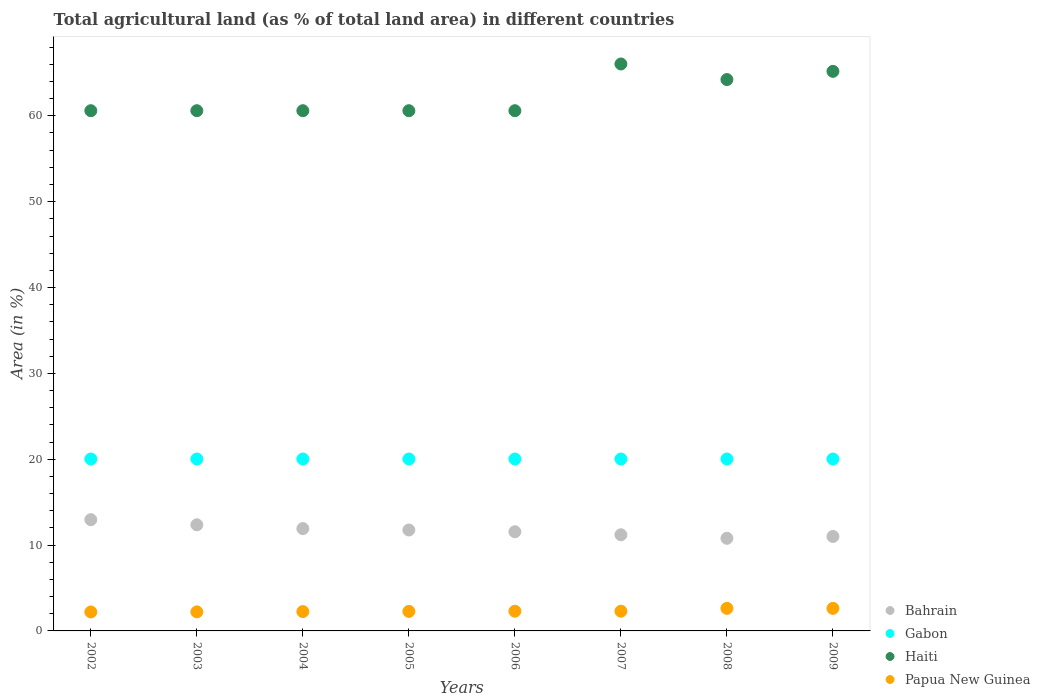What is the percentage of agricultural land in Haiti in 2004?
Keep it short and to the point. 60.6. Across all years, what is the maximum percentage of agricultural land in Haiti?
Offer a terse response. 66.04. Across all years, what is the minimum percentage of agricultural land in Papua New Guinea?
Keep it short and to the point. 2.21. In which year was the percentage of agricultural land in Bahrain maximum?
Your answer should be compact. 2002. In which year was the percentage of agricultural land in Papua New Guinea minimum?
Keep it short and to the point. 2002. What is the total percentage of agricultural land in Gabon in the graph?
Offer a very short reply. 160.2. What is the difference between the percentage of agricultural land in Bahrain in 2003 and that in 2005?
Offer a terse response. 0.6. What is the difference between the percentage of agricultural land in Haiti in 2003 and the percentage of agricultural land in Gabon in 2005?
Your answer should be very brief. 40.57. What is the average percentage of agricultural land in Bahrain per year?
Your answer should be compact. 11.69. In the year 2008, what is the difference between the percentage of agricultural land in Haiti and percentage of agricultural land in Bahrain?
Offer a very short reply. 53.43. In how many years, is the percentage of agricultural land in Gabon greater than 4 %?
Provide a succinct answer. 8. What is the ratio of the percentage of agricultural land in Haiti in 2006 to that in 2007?
Provide a succinct answer. 0.92. Is the percentage of agricultural land in Gabon in 2007 less than that in 2009?
Your response must be concise. No. Is the difference between the percentage of agricultural land in Haiti in 2004 and 2005 greater than the difference between the percentage of agricultural land in Bahrain in 2004 and 2005?
Your response must be concise. No. What is the difference between the highest and the second highest percentage of agricultural land in Bahrain?
Your answer should be very brief. 0.6. What is the difference between the highest and the lowest percentage of agricultural land in Papua New Guinea?
Your answer should be very brief. 0.42. Is it the case that in every year, the sum of the percentage of agricultural land in Papua New Guinea and percentage of agricultural land in Gabon  is greater than the sum of percentage of agricultural land in Haiti and percentage of agricultural land in Bahrain?
Provide a succinct answer. No. Is it the case that in every year, the sum of the percentage of agricultural land in Bahrain and percentage of agricultural land in Papua New Guinea  is greater than the percentage of agricultural land in Gabon?
Give a very brief answer. No. Is the percentage of agricultural land in Bahrain strictly greater than the percentage of agricultural land in Papua New Guinea over the years?
Provide a short and direct response. Yes. Is the percentage of agricultural land in Bahrain strictly less than the percentage of agricultural land in Papua New Guinea over the years?
Keep it short and to the point. No. How many dotlines are there?
Provide a succinct answer. 4. What is the difference between two consecutive major ticks on the Y-axis?
Ensure brevity in your answer.  10. Does the graph contain grids?
Make the answer very short. No. Where does the legend appear in the graph?
Provide a short and direct response. Bottom right. How are the legend labels stacked?
Provide a short and direct response. Vertical. What is the title of the graph?
Make the answer very short. Total agricultural land (as % of total land area) in different countries. Does "Norway" appear as one of the legend labels in the graph?
Provide a short and direct response. No. What is the label or title of the Y-axis?
Provide a succinct answer. Area (in %). What is the Area (in %) in Bahrain in 2002?
Your answer should be very brief. 12.96. What is the Area (in %) in Gabon in 2002?
Offer a terse response. 20.03. What is the Area (in %) of Haiti in 2002?
Provide a succinct answer. 60.6. What is the Area (in %) of Papua New Guinea in 2002?
Ensure brevity in your answer.  2.21. What is the Area (in %) in Bahrain in 2003?
Your response must be concise. 12.36. What is the Area (in %) of Gabon in 2003?
Your response must be concise. 20.03. What is the Area (in %) in Haiti in 2003?
Your response must be concise. 60.6. What is the Area (in %) of Papua New Guinea in 2003?
Make the answer very short. 2.22. What is the Area (in %) in Bahrain in 2004?
Your answer should be compact. 11.92. What is the Area (in %) in Gabon in 2004?
Provide a short and direct response. 20.03. What is the Area (in %) in Haiti in 2004?
Your answer should be very brief. 60.6. What is the Area (in %) of Papua New Guinea in 2004?
Provide a short and direct response. 2.25. What is the Area (in %) of Bahrain in 2005?
Offer a very short reply. 11.76. What is the Area (in %) in Gabon in 2005?
Offer a very short reply. 20.03. What is the Area (in %) of Haiti in 2005?
Give a very brief answer. 60.6. What is the Area (in %) of Papua New Guinea in 2005?
Offer a terse response. 2.27. What is the Area (in %) in Bahrain in 2006?
Provide a short and direct response. 11.55. What is the Area (in %) of Gabon in 2006?
Make the answer very short. 20.03. What is the Area (in %) in Haiti in 2006?
Make the answer very short. 60.6. What is the Area (in %) of Papua New Guinea in 2006?
Your answer should be compact. 2.3. What is the Area (in %) of Gabon in 2007?
Provide a short and direct response. 20.03. What is the Area (in %) in Haiti in 2007?
Ensure brevity in your answer.  66.04. What is the Area (in %) of Papua New Guinea in 2007?
Offer a terse response. 2.3. What is the Area (in %) of Bahrain in 2008?
Give a very brief answer. 10.79. What is the Area (in %) of Gabon in 2008?
Ensure brevity in your answer.  20.03. What is the Area (in %) in Haiti in 2008?
Offer a very short reply. 64.22. What is the Area (in %) of Papua New Guinea in 2008?
Provide a short and direct response. 2.63. What is the Area (in %) in Bahrain in 2009?
Ensure brevity in your answer.  11. What is the Area (in %) in Gabon in 2009?
Offer a very short reply. 20.03. What is the Area (in %) of Haiti in 2009?
Offer a very short reply. 65.18. What is the Area (in %) of Papua New Guinea in 2009?
Provide a succinct answer. 2.63. Across all years, what is the maximum Area (in %) in Bahrain?
Your answer should be compact. 12.96. Across all years, what is the maximum Area (in %) of Gabon?
Your response must be concise. 20.03. Across all years, what is the maximum Area (in %) of Haiti?
Your response must be concise. 66.04. Across all years, what is the maximum Area (in %) in Papua New Guinea?
Make the answer very short. 2.63. Across all years, what is the minimum Area (in %) of Bahrain?
Offer a very short reply. 10.79. Across all years, what is the minimum Area (in %) in Gabon?
Your answer should be very brief. 20.03. Across all years, what is the minimum Area (in %) in Haiti?
Offer a very short reply. 60.6. Across all years, what is the minimum Area (in %) of Papua New Guinea?
Offer a very short reply. 2.21. What is the total Area (in %) in Bahrain in the graph?
Your response must be concise. 93.54. What is the total Area (in %) in Gabon in the graph?
Offer a terse response. 160.2. What is the total Area (in %) of Haiti in the graph?
Offer a terse response. 498.42. What is the total Area (in %) of Papua New Guinea in the graph?
Make the answer very short. 18.8. What is the difference between the Area (in %) in Bahrain in 2002 and that in 2003?
Offer a very short reply. 0.6. What is the difference between the Area (in %) in Gabon in 2002 and that in 2003?
Offer a terse response. 0. What is the difference between the Area (in %) in Haiti in 2002 and that in 2003?
Your answer should be very brief. 0. What is the difference between the Area (in %) in Papua New Guinea in 2002 and that in 2003?
Offer a terse response. -0.01. What is the difference between the Area (in %) of Bahrain in 2002 and that in 2004?
Give a very brief answer. 1.04. What is the difference between the Area (in %) of Haiti in 2002 and that in 2004?
Ensure brevity in your answer.  0. What is the difference between the Area (in %) of Papua New Guinea in 2002 and that in 2004?
Your answer should be compact. -0.04. What is the difference between the Area (in %) in Bahrain in 2002 and that in 2005?
Your response must be concise. 1.2. What is the difference between the Area (in %) in Gabon in 2002 and that in 2005?
Offer a very short reply. 0. What is the difference between the Area (in %) of Papua New Guinea in 2002 and that in 2005?
Provide a succinct answer. -0.07. What is the difference between the Area (in %) in Bahrain in 2002 and that in 2006?
Your answer should be compact. 1.4. What is the difference between the Area (in %) in Papua New Guinea in 2002 and that in 2006?
Offer a terse response. -0.09. What is the difference between the Area (in %) in Bahrain in 2002 and that in 2007?
Keep it short and to the point. 1.76. What is the difference between the Area (in %) in Gabon in 2002 and that in 2007?
Offer a terse response. 0. What is the difference between the Area (in %) of Haiti in 2002 and that in 2007?
Keep it short and to the point. -5.44. What is the difference between the Area (in %) of Papua New Guinea in 2002 and that in 2007?
Give a very brief answer. -0.09. What is the difference between the Area (in %) in Bahrain in 2002 and that in 2008?
Provide a short and direct response. 2.17. What is the difference between the Area (in %) of Haiti in 2002 and that in 2008?
Keep it short and to the point. -3.63. What is the difference between the Area (in %) in Papua New Guinea in 2002 and that in 2008?
Make the answer very short. -0.42. What is the difference between the Area (in %) in Bahrain in 2002 and that in 2009?
Give a very brief answer. 1.96. What is the difference between the Area (in %) in Gabon in 2002 and that in 2009?
Provide a succinct answer. 0. What is the difference between the Area (in %) in Haiti in 2002 and that in 2009?
Offer a very short reply. -4.58. What is the difference between the Area (in %) of Papua New Guinea in 2002 and that in 2009?
Your answer should be very brief. -0.42. What is the difference between the Area (in %) in Bahrain in 2003 and that in 2004?
Your answer should be very brief. 0.44. What is the difference between the Area (in %) in Gabon in 2003 and that in 2004?
Ensure brevity in your answer.  0. What is the difference between the Area (in %) in Papua New Guinea in 2003 and that in 2004?
Make the answer very short. -0.03. What is the difference between the Area (in %) in Bahrain in 2003 and that in 2005?
Your answer should be very brief. 0.6. What is the difference between the Area (in %) of Gabon in 2003 and that in 2005?
Offer a very short reply. 0. What is the difference between the Area (in %) in Papua New Guinea in 2003 and that in 2005?
Offer a very short reply. -0.06. What is the difference between the Area (in %) of Bahrain in 2003 and that in 2006?
Give a very brief answer. 0.81. What is the difference between the Area (in %) in Papua New Guinea in 2003 and that in 2006?
Offer a very short reply. -0.08. What is the difference between the Area (in %) in Bahrain in 2003 and that in 2007?
Provide a short and direct response. 1.16. What is the difference between the Area (in %) of Gabon in 2003 and that in 2007?
Make the answer very short. 0. What is the difference between the Area (in %) in Haiti in 2003 and that in 2007?
Offer a very short reply. -5.44. What is the difference between the Area (in %) in Papua New Guinea in 2003 and that in 2007?
Your answer should be very brief. -0.08. What is the difference between the Area (in %) of Bahrain in 2003 and that in 2008?
Offer a very short reply. 1.57. What is the difference between the Area (in %) of Gabon in 2003 and that in 2008?
Your response must be concise. 0. What is the difference between the Area (in %) of Haiti in 2003 and that in 2008?
Make the answer very short. -3.63. What is the difference between the Area (in %) of Papua New Guinea in 2003 and that in 2008?
Provide a succinct answer. -0.41. What is the difference between the Area (in %) of Bahrain in 2003 and that in 2009?
Give a very brief answer. 1.36. What is the difference between the Area (in %) of Haiti in 2003 and that in 2009?
Offer a terse response. -4.58. What is the difference between the Area (in %) in Papua New Guinea in 2003 and that in 2009?
Keep it short and to the point. -0.41. What is the difference between the Area (in %) in Bahrain in 2004 and that in 2005?
Give a very brief answer. 0.16. What is the difference between the Area (in %) in Haiti in 2004 and that in 2005?
Provide a short and direct response. 0. What is the difference between the Area (in %) of Papua New Guinea in 2004 and that in 2005?
Provide a short and direct response. -0.02. What is the difference between the Area (in %) of Bahrain in 2004 and that in 2006?
Your answer should be very brief. 0.36. What is the difference between the Area (in %) in Papua New Guinea in 2004 and that in 2006?
Your response must be concise. -0.04. What is the difference between the Area (in %) of Bahrain in 2004 and that in 2007?
Provide a short and direct response. 0.72. What is the difference between the Area (in %) in Haiti in 2004 and that in 2007?
Your response must be concise. -5.44. What is the difference between the Area (in %) in Papua New Guinea in 2004 and that in 2007?
Ensure brevity in your answer.  -0.04. What is the difference between the Area (in %) of Bahrain in 2004 and that in 2008?
Offer a very short reply. 1.13. What is the difference between the Area (in %) in Gabon in 2004 and that in 2008?
Make the answer very short. 0. What is the difference between the Area (in %) in Haiti in 2004 and that in 2008?
Your response must be concise. -3.63. What is the difference between the Area (in %) of Papua New Guinea in 2004 and that in 2008?
Offer a very short reply. -0.38. What is the difference between the Area (in %) in Bahrain in 2004 and that in 2009?
Your answer should be very brief. 0.92. What is the difference between the Area (in %) of Haiti in 2004 and that in 2009?
Ensure brevity in your answer.  -4.58. What is the difference between the Area (in %) of Papua New Guinea in 2004 and that in 2009?
Offer a very short reply. -0.38. What is the difference between the Area (in %) of Bahrain in 2005 and that in 2006?
Provide a succinct answer. 0.2. What is the difference between the Area (in %) of Gabon in 2005 and that in 2006?
Make the answer very short. 0. What is the difference between the Area (in %) in Papua New Guinea in 2005 and that in 2006?
Your response must be concise. -0.02. What is the difference between the Area (in %) of Bahrain in 2005 and that in 2007?
Your answer should be compact. 0.56. What is the difference between the Area (in %) of Haiti in 2005 and that in 2007?
Your answer should be compact. -5.44. What is the difference between the Area (in %) in Papua New Guinea in 2005 and that in 2007?
Offer a very short reply. -0.02. What is the difference between the Area (in %) in Bahrain in 2005 and that in 2008?
Offer a very short reply. 0.97. What is the difference between the Area (in %) in Haiti in 2005 and that in 2008?
Your response must be concise. -3.63. What is the difference between the Area (in %) in Papua New Guinea in 2005 and that in 2008?
Offer a very short reply. -0.35. What is the difference between the Area (in %) in Bahrain in 2005 and that in 2009?
Provide a short and direct response. 0.76. What is the difference between the Area (in %) in Gabon in 2005 and that in 2009?
Give a very brief answer. 0. What is the difference between the Area (in %) in Haiti in 2005 and that in 2009?
Keep it short and to the point. -4.58. What is the difference between the Area (in %) in Papua New Guinea in 2005 and that in 2009?
Provide a succinct answer. -0.35. What is the difference between the Area (in %) of Bahrain in 2006 and that in 2007?
Provide a succinct answer. 0.35. What is the difference between the Area (in %) in Haiti in 2006 and that in 2007?
Ensure brevity in your answer.  -5.44. What is the difference between the Area (in %) of Bahrain in 2006 and that in 2008?
Your answer should be compact. 0.76. What is the difference between the Area (in %) of Gabon in 2006 and that in 2008?
Ensure brevity in your answer.  0. What is the difference between the Area (in %) in Haiti in 2006 and that in 2008?
Give a very brief answer. -3.63. What is the difference between the Area (in %) of Papua New Guinea in 2006 and that in 2008?
Keep it short and to the point. -0.33. What is the difference between the Area (in %) of Bahrain in 2006 and that in 2009?
Give a very brief answer. 0.55. What is the difference between the Area (in %) in Gabon in 2006 and that in 2009?
Your answer should be very brief. 0. What is the difference between the Area (in %) of Haiti in 2006 and that in 2009?
Provide a short and direct response. -4.58. What is the difference between the Area (in %) in Papua New Guinea in 2006 and that in 2009?
Ensure brevity in your answer.  -0.33. What is the difference between the Area (in %) of Bahrain in 2007 and that in 2008?
Give a very brief answer. 0.41. What is the difference between the Area (in %) in Gabon in 2007 and that in 2008?
Your response must be concise. 0. What is the difference between the Area (in %) of Haiti in 2007 and that in 2008?
Your response must be concise. 1.81. What is the difference between the Area (in %) of Papua New Guinea in 2007 and that in 2008?
Offer a terse response. -0.33. What is the difference between the Area (in %) of Bahrain in 2007 and that in 2009?
Ensure brevity in your answer.  0.2. What is the difference between the Area (in %) of Haiti in 2007 and that in 2009?
Provide a short and direct response. 0.86. What is the difference between the Area (in %) of Papua New Guinea in 2007 and that in 2009?
Your answer should be very brief. -0.33. What is the difference between the Area (in %) of Bahrain in 2008 and that in 2009?
Provide a short and direct response. -0.21. What is the difference between the Area (in %) of Gabon in 2008 and that in 2009?
Your answer should be very brief. 0. What is the difference between the Area (in %) in Haiti in 2008 and that in 2009?
Provide a succinct answer. -0.96. What is the difference between the Area (in %) of Bahrain in 2002 and the Area (in %) of Gabon in 2003?
Keep it short and to the point. -7.07. What is the difference between the Area (in %) in Bahrain in 2002 and the Area (in %) in Haiti in 2003?
Keep it short and to the point. -47.64. What is the difference between the Area (in %) of Bahrain in 2002 and the Area (in %) of Papua New Guinea in 2003?
Make the answer very short. 10.74. What is the difference between the Area (in %) in Gabon in 2002 and the Area (in %) in Haiti in 2003?
Offer a very short reply. -40.57. What is the difference between the Area (in %) of Gabon in 2002 and the Area (in %) of Papua New Guinea in 2003?
Keep it short and to the point. 17.81. What is the difference between the Area (in %) in Haiti in 2002 and the Area (in %) in Papua New Guinea in 2003?
Give a very brief answer. 58.38. What is the difference between the Area (in %) in Bahrain in 2002 and the Area (in %) in Gabon in 2004?
Your answer should be compact. -7.07. What is the difference between the Area (in %) of Bahrain in 2002 and the Area (in %) of Haiti in 2004?
Ensure brevity in your answer.  -47.64. What is the difference between the Area (in %) in Bahrain in 2002 and the Area (in %) in Papua New Guinea in 2004?
Give a very brief answer. 10.71. What is the difference between the Area (in %) in Gabon in 2002 and the Area (in %) in Haiti in 2004?
Your answer should be very brief. -40.57. What is the difference between the Area (in %) of Gabon in 2002 and the Area (in %) of Papua New Guinea in 2004?
Provide a succinct answer. 17.77. What is the difference between the Area (in %) in Haiti in 2002 and the Area (in %) in Papua New Guinea in 2004?
Keep it short and to the point. 58.34. What is the difference between the Area (in %) of Bahrain in 2002 and the Area (in %) of Gabon in 2005?
Your answer should be compact. -7.07. What is the difference between the Area (in %) of Bahrain in 2002 and the Area (in %) of Haiti in 2005?
Ensure brevity in your answer.  -47.64. What is the difference between the Area (in %) in Bahrain in 2002 and the Area (in %) in Papua New Guinea in 2005?
Provide a succinct answer. 10.68. What is the difference between the Area (in %) of Gabon in 2002 and the Area (in %) of Haiti in 2005?
Ensure brevity in your answer.  -40.57. What is the difference between the Area (in %) in Gabon in 2002 and the Area (in %) in Papua New Guinea in 2005?
Make the answer very short. 17.75. What is the difference between the Area (in %) of Haiti in 2002 and the Area (in %) of Papua New Guinea in 2005?
Make the answer very short. 58.32. What is the difference between the Area (in %) of Bahrain in 2002 and the Area (in %) of Gabon in 2006?
Your response must be concise. -7.07. What is the difference between the Area (in %) in Bahrain in 2002 and the Area (in %) in Haiti in 2006?
Make the answer very short. -47.64. What is the difference between the Area (in %) of Bahrain in 2002 and the Area (in %) of Papua New Guinea in 2006?
Your response must be concise. 10.66. What is the difference between the Area (in %) of Gabon in 2002 and the Area (in %) of Haiti in 2006?
Offer a very short reply. -40.57. What is the difference between the Area (in %) of Gabon in 2002 and the Area (in %) of Papua New Guinea in 2006?
Give a very brief answer. 17.73. What is the difference between the Area (in %) of Haiti in 2002 and the Area (in %) of Papua New Guinea in 2006?
Provide a short and direct response. 58.3. What is the difference between the Area (in %) of Bahrain in 2002 and the Area (in %) of Gabon in 2007?
Make the answer very short. -7.07. What is the difference between the Area (in %) in Bahrain in 2002 and the Area (in %) in Haiti in 2007?
Keep it short and to the point. -53.08. What is the difference between the Area (in %) of Bahrain in 2002 and the Area (in %) of Papua New Guinea in 2007?
Your answer should be very brief. 10.66. What is the difference between the Area (in %) in Gabon in 2002 and the Area (in %) in Haiti in 2007?
Provide a succinct answer. -46.01. What is the difference between the Area (in %) in Gabon in 2002 and the Area (in %) in Papua New Guinea in 2007?
Offer a very short reply. 17.73. What is the difference between the Area (in %) of Haiti in 2002 and the Area (in %) of Papua New Guinea in 2007?
Make the answer very short. 58.3. What is the difference between the Area (in %) of Bahrain in 2002 and the Area (in %) of Gabon in 2008?
Your answer should be compact. -7.07. What is the difference between the Area (in %) in Bahrain in 2002 and the Area (in %) in Haiti in 2008?
Offer a very short reply. -51.27. What is the difference between the Area (in %) in Bahrain in 2002 and the Area (in %) in Papua New Guinea in 2008?
Your answer should be very brief. 10.33. What is the difference between the Area (in %) of Gabon in 2002 and the Area (in %) of Haiti in 2008?
Offer a very short reply. -44.2. What is the difference between the Area (in %) of Gabon in 2002 and the Area (in %) of Papua New Guinea in 2008?
Make the answer very short. 17.4. What is the difference between the Area (in %) of Haiti in 2002 and the Area (in %) of Papua New Guinea in 2008?
Give a very brief answer. 57.97. What is the difference between the Area (in %) in Bahrain in 2002 and the Area (in %) in Gabon in 2009?
Provide a succinct answer. -7.07. What is the difference between the Area (in %) in Bahrain in 2002 and the Area (in %) in Haiti in 2009?
Give a very brief answer. -52.22. What is the difference between the Area (in %) of Bahrain in 2002 and the Area (in %) of Papua New Guinea in 2009?
Ensure brevity in your answer.  10.33. What is the difference between the Area (in %) in Gabon in 2002 and the Area (in %) in Haiti in 2009?
Provide a succinct answer. -45.15. What is the difference between the Area (in %) in Gabon in 2002 and the Area (in %) in Papua New Guinea in 2009?
Your response must be concise. 17.4. What is the difference between the Area (in %) in Haiti in 2002 and the Area (in %) in Papua New Guinea in 2009?
Keep it short and to the point. 57.97. What is the difference between the Area (in %) in Bahrain in 2003 and the Area (in %) in Gabon in 2004?
Make the answer very short. -7.66. What is the difference between the Area (in %) of Bahrain in 2003 and the Area (in %) of Haiti in 2004?
Make the answer very short. -48.23. What is the difference between the Area (in %) in Bahrain in 2003 and the Area (in %) in Papua New Guinea in 2004?
Provide a succinct answer. 10.11. What is the difference between the Area (in %) in Gabon in 2003 and the Area (in %) in Haiti in 2004?
Provide a short and direct response. -40.57. What is the difference between the Area (in %) of Gabon in 2003 and the Area (in %) of Papua New Guinea in 2004?
Ensure brevity in your answer.  17.77. What is the difference between the Area (in %) in Haiti in 2003 and the Area (in %) in Papua New Guinea in 2004?
Give a very brief answer. 58.34. What is the difference between the Area (in %) in Bahrain in 2003 and the Area (in %) in Gabon in 2005?
Offer a terse response. -7.66. What is the difference between the Area (in %) in Bahrain in 2003 and the Area (in %) in Haiti in 2005?
Your answer should be compact. -48.23. What is the difference between the Area (in %) in Bahrain in 2003 and the Area (in %) in Papua New Guinea in 2005?
Your answer should be very brief. 10.09. What is the difference between the Area (in %) in Gabon in 2003 and the Area (in %) in Haiti in 2005?
Your response must be concise. -40.57. What is the difference between the Area (in %) in Gabon in 2003 and the Area (in %) in Papua New Guinea in 2005?
Give a very brief answer. 17.75. What is the difference between the Area (in %) in Haiti in 2003 and the Area (in %) in Papua New Guinea in 2005?
Keep it short and to the point. 58.32. What is the difference between the Area (in %) of Bahrain in 2003 and the Area (in %) of Gabon in 2006?
Give a very brief answer. -7.66. What is the difference between the Area (in %) of Bahrain in 2003 and the Area (in %) of Haiti in 2006?
Your answer should be compact. -48.23. What is the difference between the Area (in %) in Bahrain in 2003 and the Area (in %) in Papua New Guinea in 2006?
Offer a terse response. 10.06. What is the difference between the Area (in %) in Gabon in 2003 and the Area (in %) in Haiti in 2006?
Keep it short and to the point. -40.57. What is the difference between the Area (in %) in Gabon in 2003 and the Area (in %) in Papua New Guinea in 2006?
Your answer should be very brief. 17.73. What is the difference between the Area (in %) of Haiti in 2003 and the Area (in %) of Papua New Guinea in 2006?
Keep it short and to the point. 58.3. What is the difference between the Area (in %) in Bahrain in 2003 and the Area (in %) in Gabon in 2007?
Keep it short and to the point. -7.66. What is the difference between the Area (in %) of Bahrain in 2003 and the Area (in %) of Haiti in 2007?
Provide a short and direct response. -53.68. What is the difference between the Area (in %) of Bahrain in 2003 and the Area (in %) of Papua New Guinea in 2007?
Provide a succinct answer. 10.06. What is the difference between the Area (in %) of Gabon in 2003 and the Area (in %) of Haiti in 2007?
Your answer should be very brief. -46.01. What is the difference between the Area (in %) of Gabon in 2003 and the Area (in %) of Papua New Guinea in 2007?
Keep it short and to the point. 17.73. What is the difference between the Area (in %) of Haiti in 2003 and the Area (in %) of Papua New Guinea in 2007?
Your answer should be very brief. 58.3. What is the difference between the Area (in %) in Bahrain in 2003 and the Area (in %) in Gabon in 2008?
Offer a terse response. -7.66. What is the difference between the Area (in %) of Bahrain in 2003 and the Area (in %) of Haiti in 2008?
Offer a very short reply. -51.86. What is the difference between the Area (in %) in Bahrain in 2003 and the Area (in %) in Papua New Guinea in 2008?
Offer a terse response. 9.73. What is the difference between the Area (in %) of Gabon in 2003 and the Area (in %) of Haiti in 2008?
Provide a succinct answer. -44.2. What is the difference between the Area (in %) of Gabon in 2003 and the Area (in %) of Papua New Guinea in 2008?
Your answer should be very brief. 17.4. What is the difference between the Area (in %) in Haiti in 2003 and the Area (in %) in Papua New Guinea in 2008?
Provide a succinct answer. 57.97. What is the difference between the Area (in %) in Bahrain in 2003 and the Area (in %) in Gabon in 2009?
Keep it short and to the point. -7.66. What is the difference between the Area (in %) in Bahrain in 2003 and the Area (in %) in Haiti in 2009?
Offer a terse response. -52.82. What is the difference between the Area (in %) in Bahrain in 2003 and the Area (in %) in Papua New Guinea in 2009?
Ensure brevity in your answer.  9.73. What is the difference between the Area (in %) of Gabon in 2003 and the Area (in %) of Haiti in 2009?
Give a very brief answer. -45.15. What is the difference between the Area (in %) in Gabon in 2003 and the Area (in %) in Papua New Guinea in 2009?
Offer a very short reply. 17.4. What is the difference between the Area (in %) of Haiti in 2003 and the Area (in %) of Papua New Guinea in 2009?
Give a very brief answer. 57.97. What is the difference between the Area (in %) in Bahrain in 2004 and the Area (in %) in Gabon in 2005?
Offer a terse response. -8.11. What is the difference between the Area (in %) in Bahrain in 2004 and the Area (in %) in Haiti in 2005?
Make the answer very short. -48.68. What is the difference between the Area (in %) of Bahrain in 2004 and the Area (in %) of Papua New Guinea in 2005?
Make the answer very short. 9.64. What is the difference between the Area (in %) of Gabon in 2004 and the Area (in %) of Haiti in 2005?
Give a very brief answer. -40.57. What is the difference between the Area (in %) of Gabon in 2004 and the Area (in %) of Papua New Guinea in 2005?
Ensure brevity in your answer.  17.75. What is the difference between the Area (in %) of Haiti in 2004 and the Area (in %) of Papua New Guinea in 2005?
Offer a very short reply. 58.32. What is the difference between the Area (in %) of Bahrain in 2004 and the Area (in %) of Gabon in 2006?
Your response must be concise. -8.11. What is the difference between the Area (in %) of Bahrain in 2004 and the Area (in %) of Haiti in 2006?
Keep it short and to the point. -48.68. What is the difference between the Area (in %) of Bahrain in 2004 and the Area (in %) of Papua New Guinea in 2006?
Your answer should be compact. 9.62. What is the difference between the Area (in %) in Gabon in 2004 and the Area (in %) in Haiti in 2006?
Keep it short and to the point. -40.57. What is the difference between the Area (in %) in Gabon in 2004 and the Area (in %) in Papua New Guinea in 2006?
Give a very brief answer. 17.73. What is the difference between the Area (in %) of Haiti in 2004 and the Area (in %) of Papua New Guinea in 2006?
Offer a terse response. 58.3. What is the difference between the Area (in %) in Bahrain in 2004 and the Area (in %) in Gabon in 2007?
Keep it short and to the point. -8.11. What is the difference between the Area (in %) in Bahrain in 2004 and the Area (in %) in Haiti in 2007?
Offer a very short reply. -54.12. What is the difference between the Area (in %) of Bahrain in 2004 and the Area (in %) of Papua New Guinea in 2007?
Make the answer very short. 9.62. What is the difference between the Area (in %) in Gabon in 2004 and the Area (in %) in Haiti in 2007?
Keep it short and to the point. -46.01. What is the difference between the Area (in %) in Gabon in 2004 and the Area (in %) in Papua New Guinea in 2007?
Ensure brevity in your answer.  17.73. What is the difference between the Area (in %) of Haiti in 2004 and the Area (in %) of Papua New Guinea in 2007?
Give a very brief answer. 58.3. What is the difference between the Area (in %) in Bahrain in 2004 and the Area (in %) in Gabon in 2008?
Give a very brief answer. -8.11. What is the difference between the Area (in %) in Bahrain in 2004 and the Area (in %) in Haiti in 2008?
Offer a very short reply. -52.31. What is the difference between the Area (in %) in Bahrain in 2004 and the Area (in %) in Papua New Guinea in 2008?
Offer a terse response. 9.29. What is the difference between the Area (in %) of Gabon in 2004 and the Area (in %) of Haiti in 2008?
Ensure brevity in your answer.  -44.2. What is the difference between the Area (in %) in Gabon in 2004 and the Area (in %) in Papua New Guinea in 2008?
Provide a succinct answer. 17.4. What is the difference between the Area (in %) of Haiti in 2004 and the Area (in %) of Papua New Guinea in 2008?
Your answer should be very brief. 57.97. What is the difference between the Area (in %) in Bahrain in 2004 and the Area (in %) in Gabon in 2009?
Ensure brevity in your answer.  -8.11. What is the difference between the Area (in %) in Bahrain in 2004 and the Area (in %) in Haiti in 2009?
Give a very brief answer. -53.26. What is the difference between the Area (in %) of Bahrain in 2004 and the Area (in %) of Papua New Guinea in 2009?
Ensure brevity in your answer.  9.29. What is the difference between the Area (in %) of Gabon in 2004 and the Area (in %) of Haiti in 2009?
Make the answer very short. -45.15. What is the difference between the Area (in %) of Gabon in 2004 and the Area (in %) of Papua New Guinea in 2009?
Keep it short and to the point. 17.4. What is the difference between the Area (in %) in Haiti in 2004 and the Area (in %) in Papua New Guinea in 2009?
Keep it short and to the point. 57.97. What is the difference between the Area (in %) of Bahrain in 2005 and the Area (in %) of Gabon in 2006?
Make the answer very short. -8.27. What is the difference between the Area (in %) of Bahrain in 2005 and the Area (in %) of Haiti in 2006?
Offer a very short reply. -48.84. What is the difference between the Area (in %) of Bahrain in 2005 and the Area (in %) of Papua New Guinea in 2006?
Your response must be concise. 9.46. What is the difference between the Area (in %) of Gabon in 2005 and the Area (in %) of Haiti in 2006?
Your answer should be compact. -40.57. What is the difference between the Area (in %) in Gabon in 2005 and the Area (in %) in Papua New Guinea in 2006?
Keep it short and to the point. 17.73. What is the difference between the Area (in %) in Haiti in 2005 and the Area (in %) in Papua New Guinea in 2006?
Make the answer very short. 58.3. What is the difference between the Area (in %) of Bahrain in 2005 and the Area (in %) of Gabon in 2007?
Give a very brief answer. -8.27. What is the difference between the Area (in %) of Bahrain in 2005 and the Area (in %) of Haiti in 2007?
Keep it short and to the point. -54.28. What is the difference between the Area (in %) in Bahrain in 2005 and the Area (in %) in Papua New Guinea in 2007?
Your answer should be very brief. 9.46. What is the difference between the Area (in %) in Gabon in 2005 and the Area (in %) in Haiti in 2007?
Ensure brevity in your answer.  -46.01. What is the difference between the Area (in %) of Gabon in 2005 and the Area (in %) of Papua New Guinea in 2007?
Provide a succinct answer. 17.73. What is the difference between the Area (in %) of Haiti in 2005 and the Area (in %) of Papua New Guinea in 2007?
Keep it short and to the point. 58.3. What is the difference between the Area (in %) in Bahrain in 2005 and the Area (in %) in Gabon in 2008?
Make the answer very short. -8.27. What is the difference between the Area (in %) of Bahrain in 2005 and the Area (in %) of Haiti in 2008?
Offer a terse response. -52.47. What is the difference between the Area (in %) in Bahrain in 2005 and the Area (in %) in Papua New Guinea in 2008?
Offer a terse response. 9.13. What is the difference between the Area (in %) in Gabon in 2005 and the Area (in %) in Haiti in 2008?
Provide a succinct answer. -44.2. What is the difference between the Area (in %) of Gabon in 2005 and the Area (in %) of Papua New Guinea in 2008?
Give a very brief answer. 17.4. What is the difference between the Area (in %) of Haiti in 2005 and the Area (in %) of Papua New Guinea in 2008?
Offer a very short reply. 57.97. What is the difference between the Area (in %) of Bahrain in 2005 and the Area (in %) of Gabon in 2009?
Provide a short and direct response. -8.27. What is the difference between the Area (in %) in Bahrain in 2005 and the Area (in %) in Haiti in 2009?
Offer a terse response. -53.42. What is the difference between the Area (in %) of Bahrain in 2005 and the Area (in %) of Papua New Guinea in 2009?
Offer a very short reply. 9.13. What is the difference between the Area (in %) in Gabon in 2005 and the Area (in %) in Haiti in 2009?
Offer a very short reply. -45.15. What is the difference between the Area (in %) of Gabon in 2005 and the Area (in %) of Papua New Guinea in 2009?
Your answer should be compact. 17.4. What is the difference between the Area (in %) in Haiti in 2005 and the Area (in %) in Papua New Guinea in 2009?
Your response must be concise. 57.97. What is the difference between the Area (in %) in Bahrain in 2006 and the Area (in %) in Gabon in 2007?
Keep it short and to the point. -8.47. What is the difference between the Area (in %) of Bahrain in 2006 and the Area (in %) of Haiti in 2007?
Your response must be concise. -54.48. What is the difference between the Area (in %) in Bahrain in 2006 and the Area (in %) in Papua New Guinea in 2007?
Keep it short and to the point. 9.26. What is the difference between the Area (in %) in Gabon in 2006 and the Area (in %) in Haiti in 2007?
Give a very brief answer. -46.01. What is the difference between the Area (in %) in Gabon in 2006 and the Area (in %) in Papua New Guinea in 2007?
Provide a short and direct response. 17.73. What is the difference between the Area (in %) of Haiti in 2006 and the Area (in %) of Papua New Guinea in 2007?
Provide a succinct answer. 58.3. What is the difference between the Area (in %) of Bahrain in 2006 and the Area (in %) of Gabon in 2008?
Keep it short and to the point. -8.47. What is the difference between the Area (in %) of Bahrain in 2006 and the Area (in %) of Haiti in 2008?
Your answer should be compact. -52.67. What is the difference between the Area (in %) of Bahrain in 2006 and the Area (in %) of Papua New Guinea in 2008?
Offer a very short reply. 8.93. What is the difference between the Area (in %) in Gabon in 2006 and the Area (in %) in Haiti in 2008?
Provide a short and direct response. -44.2. What is the difference between the Area (in %) of Gabon in 2006 and the Area (in %) of Papua New Guinea in 2008?
Your answer should be very brief. 17.4. What is the difference between the Area (in %) in Haiti in 2006 and the Area (in %) in Papua New Guinea in 2008?
Offer a terse response. 57.97. What is the difference between the Area (in %) of Bahrain in 2006 and the Area (in %) of Gabon in 2009?
Make the answer very short. -8.47. What is the difference between the Area (in %) in Bahrain in 2006 and the Area (in %) in Haiti in 2009?
Ensure brevity in your answer.  -53.62. What is the difference between the Area (in %) in Bahrain in 2006 and the Area (in %) in Papua New Guinea in 2009?
Provide a succinct answer. 8.93. What is the difference between the Area (in %) in Gabon in 2006 and the Area (in %) in Haiti in 2009?
Provide a short and direct response. -45.15. What is the difference between the Area (in %) of Gabon in 2006 and the Area (in %) of Papua New Guinea in 2009?
Your answer should be compact. 17.4. What is the difference between the Area (in %) of Haiti in 2006 and the Area (in %) of Papua New Guinea in 2009?
Your response must be concise. 57.97. What is the difference between the Area (in %) of Bahrain in 2007 and the Area (in %) of Gabon in 2008?
Your answer should be very brief. -8.83. What is the difference between the Area (in %) of Bahrain in 2007 and the Area (in %) of Haiti in 2008?
Provide a succinct answer. -53.02. What is the difference between the Area (in %) in Bahrain in 2007 and the Area (in %) in Papua New Guinea in 2008?
Your response must be concise. 8.57. What is the difference between the Area (in %) in Gabon in 2007 and the Area (in %) in Haiti in 2008?
Your answer should be very brief. -44.2. What is the difference between the Area (in %) in Gabon in 2007 and the Area (in %) in Papua New Guinea in 2008?
Your response must be concise. 17.4. What is the difference between the Area (in %) of Haiti in 2007 and the Area (in %) of Papua New Guinea in 2008?
Your answer should be very brief. 63.41. What is the difference between the Area (in %) of Bahrain in 2007 and the Area (in %) of Gabon in 2009?
Keep it short and to the point. -8.83. What is the difference between the Area (in %) in Bahrain in 2007 and the Area (in %) in Haiti in 2009?
Your response must be concise. -53.98. What is the difference between the Area (in %) in Bahrain in 2007 and the Area (in %) in Papua New Guinea in 2009?
Provide a short and direct response. 8.57. What is the difference between the Area (in %) in Gabon in 2007 and the Area (in %) in Haiti in 2009?
Keep it short and to the point. -45.15. What is the difference between the Area (in %) of Gabon in 2007 and the Area (in %) of Papua New Guinea in 2009?
Your answer should be compact. 17.4. What is the difference between the Area (in %) of Haiti in 2007 and the Area (in %) of Papua New Guinea in 2009?
Your answer should be compact. 63.41. What is the difference between the Area (in %) in Bahrain in 2008 and the Area (in %) in Gabon in 2009?
Make the answer very short. -9.24. What is the difference between the Area (in %) in Bahrain in 2008 and the Area (in %) in Haiti in 2009?
Provide a succinct answer. -54.39. What is the difference between the Area (in %) in Bahrain in 2008 and the Area (in %) in Papua New Guinea in 2009?
Your answer should be compact. 8.16. What is the difference between the Area (in %) in Gabon in 2008 and the Area (in %) in Haiti in 2009?
Offer a very short reply. -45.15. What is the difference between the Area (in %) of Gabon in 2008 and the Area (in %) of Papua New Guinea in 2009?
Offer a very short reply. 17.4. What is the difference between the Area (in %) of Haiti in 2008 and the Area (in %) of Papua New Guinea in 2009?
Offer a very short reply. 61.6. What is the average Area (in %) of Bahrain per year?
Keep it short and to the point. 11.69. What is the average Area (in %) in Gabon per year?
Ensure brevity in your answer.  20.03. What is the average Area (in %) of Haiti per year?
Your response must be concise. 62.3. What is the average Area (in %) in Papua New Guinea per year?
Keep it short and to the point. 2.35. In the year 2002, what is the difference between the Area (in %) in Bahrain and Area (in %) in Gabon?
Your answer should be very brief. -7.07. In the year 2002, what is the difference between the Area (in %) of Bahrain and Area (in %) of Haiti?
Your answer should be compact. -47.64. In the year 2002, what is the difference between the Area (in %) in Bahrain and Area (in %) in Papua New Guinea?
Provide a succinct answer. 10.75. In the year 2002, what is the difference between the Area (in %) of Gabon and Area (in %) of Haiti?
Ensure brevity in your answer.  -40.57. In the year 2002, what is the difference between the Area (in %) of Gabon and Area (in %) of Papua New Guinea?
Provide a short and direct response. 17.82. In the year 2002, what is the difference between the Area (in %) of Haiti and Area (in %) of Papua New Guinea?
Give a very brief answer. 58.39. In the year 2003, what is the difference between the Area (in %) in Bahrain and Area (in %) in Gabon?
Offer a very short reply. -7.66. In the year 2003, what is the difference between the Area (in %) in Bahrain and Area (in %) in Haiti?
Offer a terse response. -48.23. In the year 2003, what is the difference between the Area (in %) in Bahrain and Area (in %) in Papua New Guinea?
Your answer should be compact. 10.14. In the year 2003, what is the difference between the Area (in %) of Gabon and Area (in %) of Haiti?
Ensure brevity in your answer.  -40.57. In the year 2003, what is the difference between the Area (in %) of Gabon and Area (in %) of Papua New Guinea?
Offer a terse response. 17.81. In the year 2003, what is the difference between the Area (in %) in Haiti and Area (in %) in Papua New Guinea?
Your response must be concise. 58.38. In the year 2004, what is the difference between the Area (in %) in Bahrain and Area (in %) in Gabon?
Offer a very short reply. -8.11. In the year 2004, what is the difference between the Area (in %) in Bahrain and Area (in %) in Haiti?
Give a very brief answer. -48.68. In the year 2004, what is the difference between the Area (in %) of Bahrain and Area (in %) of Papua New Guinea?
Ensure brevity in your answer.  9.67. In the year 2004, what is the difference between the Area (in %) of Gabon and Area (in %) of Haiti?
Offer a very short reply. -40.57. In the year 2004, what is the difference between the Area (in %) in Gabon and Area (in %) in Papua New Guinea?
Offer a terse response. 17.77. In the year 2004, what is the difference between the Area (in %) in Haiti and Area (in %) in Papua New Guinea?
Your answer should be very brief. 58.34. In the year 2005, what is the difference between the Area (in %) of Bahrain and Area (in %) of Gabon?
Ensure brevity in your answer.  -8.27. In the year 2005, what is the difference between the Area (in %) in Bahrain and Area (in %) in Haiti?
Your answer should be compact. -48.84. In the year 2005, what is the difference between the Area (in %) in Bahrain and Area (in %) in Papua New Guinea?
Offer a terse response. 9.48. In the year 2005, what is the difference between the Area (in %) of Gabon and Area (in %) of Haiti?
Offer a terse response. -40.57. In the year 2005, what is the difference between the Area (in %) in Gabon and Area (in %) in Papua New Guinea?
Provide a short and direct response. 17.75. In the year 2005, what is the difference between the Area (in %) of Haiti and Area (in %) of Papua New Guinea?
Provide a short and direct response. 58.32. In the year 2006, what is the difference between the Area (in %) in Bahrain and Area (in %) in Gabon?
Offer a very short reply. -8.47. In the year 2006, what is the difference between the Area (in %) in Bahrain and Area (in %) in Haiti?
Offer a terse response. -49.04. In the year 2006, what is the difference between the Area (in %) of Bahrain and Area (in %) of Papua New Guinea?
Offer a terse response. 9.26. In the year 2006, what is the difference between the Area (in %) in Gabon and Area (in %) in Haiti?
Your response must be concise. -40.57. In the year 2006, what is the difference between the Area (in %) of Gabon and Area (in %) of Papua New Guinea?
Your answer should be compact. 17.73. In the year 2006, what is the difference between the Area (in %) in Haiti and Area (in %) in Papua New Guinea?
Keep it short and to the point. 58.3. In the year 2007, what is the difference between the Area (in %) of Bahrain and Area (in %) of Gabon?
Keep it short and to the point. -8.83. In the year 2007, what is the difference between the Area (in %) in Bahrain and Area (in %) in Haiti?
Provide a succinct answer. -54.84. In the year 2007, what is the difference between the Area (in %) of Bahrain and Area (in %) of Papua New Guinea?
Ensure brevity in your answer.  8.9. In the year 2007, what is the difference between the Area (in %) in Gabon and Area (in %) in Haiti?
Keep it short and to the point. -46.01. In the year 2007, what is the difference between the Area (in %) of Gabon and Area (in %) of Papua New Guinea?
Offer a very short reply. 17.73. In the year 2007, what is the difference between the Area (in %) of Haiti and Area (in %) of Papua New Guinea?
Provide a short and direct response. 63.74. In the year 2008, what is the difference between the Area (in %) in Bahrain and Area (in %) in Gabon?
Provide a short and direct response. -9.24. In the year 2008, what is the difference between the Area (in %) in Bahrain and Area (in %) in Haiti?
Keep it short and to the point. -53.43. In the year 2008, what is the difference between the Area (in %) in Bahrain and Area (in %) in Papua New Guinea?
Provide a short and direct response. 8.16. In the year 2008, what is the difference between the Area (in %) of Gabon and Area (in %) of Haiti?
Your answer should be very brief. -44.2. In the year 2008, what is the difference between the Area (in %) of Gabon and Area (in %) of Papua New Guinea?
Your answer should be very brief. 17.4. In the year 2008, what is the difference between the Area (in %) of Haiti and Area (in %) of Papua New Guinea?
Offer a terse response. 61.6. In the year 2009, what is the difference between the Area (in %) of Bahrain and Area (in %) of Gabon?
Give a very brief answer. -9.03. In the year 2009, what is the difference between the Area (in %) of Bahrain and Area (in %) of Haiti?
Give a very brief answer. -54.18. In the year 2009, what is the difference between the Area (in %) of Bahrain and Area (in %) of Papua New Guinea?
Your response must be concise. 8.37. In the year 2009, what is the difference between the Area (in %) in Gabon and Area (in %) in Haiti?
Make the answer very short. -45.15. In the year 2009, what is the difference between the Area (in %) of Gabon and Area (in %) of Papua New Guinea?
Offer a terse response. 17.4. In the year 2009, what is the difference between the Area (in %) of Haiti and Area (in %) of Papua New Guinea?
Your response must be concise. 62.55. What is the ratio of the Area (in %) in Bahrain in 2002 to that in 2003?
Your answer should be compact. 1.05. What is the ratio of the Area (in %) of Gabon in 2002 to that in 2003?
Your answer should be compact. 1. What is the ratio of the Area (in %) of Bahrain in 2002 to that in 2004?
Keep it short and to the point. 1.09. What is the ratio of the Area (in %) of Gabon in 2002 to that in 2004?
Your answer should be very brief. 1. What is the ratio of the Area (in %) in Papua New Guinea in 2002 to that in 2004?
Keep it short and to the point. 0.98. What is the ratio of the Area (in %) in Bahrain in 2002 to that in 2005?
Provide a succinct answer. 1.1. What is the ratio of the Area (in %) of Gabon in 2002 to that in 2005?
Offer a very short reply. 1. What is the ratio of the Area (in %) in Papua New Guinea in 2002 to that in 2005?
Offer a terse response. 0.97. What is the ratio of the Area (in %) of Bahrain in 2002 to that in 2006?
Give a very brief answer. 1.12. What is the ratio of the Area (in %) in Gabon in 2002 to that in 2006?
Provide a short and direct response. 1. What is the ratio of the Area (in %) of Haiti in 2002 to that in 2006?
Your answer should be compact. 1. What is the ratio of the Area (in %) of Papua New Guinea in 2002 to that in 2006?
Your answer should be very brief. 0.96. What is the ratio of the Area (in %) of Bahrain in 2002 to that in 2007?
Ensure brevity in your answer.  1.16. What is the ratio of the Area (in %) in Gabon in 2002 to that in 2007?
Your response must be concise. 1. What is the ratio of the Area (in %) of Haiti in 2002 to that in 2007?
Keep it short and to the point. 0.92. What is the ratio of the Area (in %) of Papua New Guinea in 2002 to that in 2007?
Make the answer very short. 0.96. What is the ratio of the Area (in %) in Bahrain in 2002 to that in 2008?
Provide a succinct answer. 1.2. What is the ratio of the Area (in %) of Gabon in 2002 to that in 2008?
Provide a succinct answer. 1. What is the ratio of the Area (in %) in Haiti in 2002 to that in 2008?
Make the answer very short. 0.94. What is the ratio of the Area (in %) of Papua New Guinea in 2002 to that in 2008?
Give a very brief answer. 0.84. What is the ratio of the Area (in %) of Bahrain in 2002 to that in 2009?
Your response must be concise. 1.18. What is the ratio of the Area (in %) in Haiti in 2002 to that in 2009?
Offer a terse response. 0.93. What is the ratio of the Area (in %) in Papua New Guinea in 2002 to that in 2009?
Make the answer very short. 0.84. What is the ratio of the Area (in %) in Bahrain in 2003 to that in 2004?
Your response must be concise. 1.04. What is the ratio of the Area (in %) in Gabon in 2003 to that in 2004?
Give a very brief answer. 1. What is the ratio of the Area (in %) of Haiti in 2003 to that in 2004?
Offer a very short reply. 1. What is the ratio of the Area (in %) of Papua New Guinea in 2003 to that in 2004?
Offer a very short reply. 0.99. What is the ratio of the Area (in %) of Bahrain in 2003 to that in 2005?
Keep it short and to the point. 1.05. What is the ratio of the Area (in %) in Gabon in 2003 to that in 2005?
Your response must be concise. 1. What is the ratio of the Area (in %) of Papua New Guinea in 2003 to that in 2005?
Your response must be concise. 0.98. What is the ratio of the Area (in %) of Bahrain in 2003 to that in 2006?
Your answer should be very brief. 1.07. What is the ratio of the Area (in %) of Gabon in 2003 to that in 2006?
Make the answer very short. 1. What is the ratio of the Area (in %) of Papua New Guinea in 2003 to that in 2006?
Give a very brief answer. 0.97. What is the ratio of the Area (in %) of Bahrain in 2003 to that in 2007?
Offer a terse response. 1.1. What is the ratio of the Area (in %) in Haiti in 2003 to that in 2007?
Provide a succinct answer. 0.92. What is the ratio of the Area (in %) in Papua New Guinea in 2003 to that in 2007?
Offer a very short reply. 0.97. What is the ratio of the Area (in %) in Bahrain in 2003 to that in 2008?
Your response must be concise. 1.15. What is the ratio of the Area (in %) in Haiti in 2003 to that in 2008?
Offer a very short reply. 0.94. What is the ratio of the Area (in %) of Papua New Guinea in 2003 to that in 2008?
Make the answer very short. 0.84. What is the ratio of the Area (in %) in Bahrain in 2003 to that in 2009?
Give a very brief answer. 1.12. What is the ratio of the Area (in %) in Haiti in 2003 to that in 2009?
Your response must be concise. 0.93. What is the ratio of the Area (in %) in Papua New Guinea in 2003 to that in 2009?
Your answer should be very brief. 0.84. What is the ratio of the Area (in %) of Bahrain in 2004 to that in 2005?
Make the answer very short. 1.01. What is the ratio of the Area (in %) in Gabon in 2004 to that in 2005?
Your answer should be compact. 1. What is the ratio of the Area (in %) in Papua New Guinea in 2004 to that in 2005?
Ensure brevity in your answer.  0.99. What is the ratio of the Area (in %) in Bahrain in 2004 to that in 2006?
Provide a short and direct response. 1.03. What is the ratio of the Area (in %) of Haiti in 2004 to that in 2006?
Provide a succinct answer. 1. What is the ratio of the Area (in %) in Papua New Guinea in 2004 to that in 2006?
Provide a succinct answer. 0.98. What is the ratio of the Area (in %) in Bahrain in 2004 to that in 2007?
Keep it short and to the point. 1.06. What is the ratio of the Area (in %) in Gabon in 2004 to that in 2007?
Offer a very short reply. 1. What is the ratio of the Area (in %) of Haiti in 2004 to that in 2007?
Offer a very short reply. 0.92. What is the ratio of the Area (in %) in Papua New Guinea in 2004 to that in 2007?
Give a very brief answer. 0.98. What is the ratio of the Area (in %) in Bahrain in 2004 to that in 2008?
Your response must be concise. 1.1. What is the ratio of the Area (in %) in Gabon in 2004 to that in 2008?
Ensure brevity in your answer.  1. What is the ratio of the Area (in %) in Haiti in 2004 to that in 2008?
Your answer should be very brief. 0.94. What is the ratio of the Area (in %) of Papua New Guinea in 2004 to that in 2008?
Your response must be concise. 0.86. What is the ratio of the Area (in %) of Bahrain in 2004 to that in 2009?
Offer a very short reply. 1.08. What is the ratio of the Area (in %) in Haiti in 2004 to that in 2009?
Make the answer very short. 0.93. What is the ratio of the Area (in %) in Papua New Guinea in 2004 to that in 2009?
Keep it short and to the point. 0.86. What is the ratio of the Area (in %) of Bahrain in 2005 to that in 2006?
Provide a succinct answer. 1.02. What is the ratio of the Area (in %) of Bahrain in 2005 to that in 2007?
Your response must be concise. 1.05. What is the ratio of the Area (in %) of Gabon in 2005 to that in 2007?
Provide a succinct answer. 1. What is the ratio of the Area (in %) in Haiti in 2005 to that in 2007?
Offer a very short reply. 0.92. What is the ratio of the Area (in %) of Papua New Guinea in 2005 to that in 2007?
Make the answer very short. 0.99. What is the ratio of the Area (in %) of Bahrain in 2005 to that in 2008?
Provide a short and direct response. 1.09. What is the ratio of the Area (in %) of Gabon in 2005 to that in 2008?
Offer a terse response. 1. What is the ratio of the Area (in %) in Haiti in 2005 to that in 2008?
Make the answer very short. 0.94. What is the ratio of the Area (in %) in Papua New Guinea in 2005 to that in 2008?
Your answer should be very brief. 0.87. What is the ratio of the Area (in %) in Bahrain in 2005 to that in 2009?
Offer a very short reply. 1.07. What is the ratio of the Area (in %) of Haiti in 2005 to that in 2009?
Keep it short and to the point. 0.93. What is the ratio of the Area (in %) in Papua New Guinea in 2005 to that in 2009?
Offer a terse response. 0.87. What is the ratio of the Area (in %) of Bahrain in 2006 to that in 2007?
Your answer should be compact. 1.03. What is the ratio of the Area (in %) of Haiti in 2006 to that in 2007?
Offer a very short reply. 0.92. What is the ratio of the Area (in %) of Papua New Guinea in 2006 to that in 2007?
Keep it short and to the point. 1. What is the ratio of the Area (in %) in Bahrain in 2006 to that in 2008?
Your answer should be very brief. 1.07. What is the ratio of the Area (in %) in Gabon in 2006 to that in 2008?
Ensure brevity in your answer.  1. What is the ratio of the Area (in %) of Haiti in 2006 to that in 2008?
Offer a terse response. 0.94. What is the ratio of the Area (in %) of Papua New Guinea in 2006 to that in 2008?
Offer a very short reply. 0.87. What is the ratio of the Area (in %) of Bahrain in 2006 to that in 2009?
Give a very brief answer. 1.05. What is the ratio of the Area (in %) in Gabon in 2006 to that in 2009?
Offer a terse response. 1. What is the ratio of the Area (in %) in Haiti in 2006 to that in 2009?
Offer a very short reply. 0.93. What is the ratio of the Area (in %) of Papua New Guinea in 2006 to that in 2009?
Your answer should be compact. 0.87. What is the ratio of the Area (in %) in Bahrain in 2007 to that in 2008?
Offer a very short reply. 1.04. What is the ratio of the Area (in %) of Haiti in 2007 to that in 2008?
Give a very brief answer. 1.03. What is the ratio of the Area (in %) of Papua New Guinea in 2007 to that in 2008?
Offer a very short reply. 0.87. What is the ratio of the Area (in %) of Bahrain in 2007 to that in 2009?
Your answer should be compact. 1.02. What is the ratio of the Area (in %) in Gabon in 2007 to that in 2009?
Provide a succinct answer. 1. What is the ratio of the Area (in %) of Haiti in 2007 to that in 2009?
Offer a very short reply. 1.01. What is the ratio of the Area (in %) of Papua New Guinea in 2007 to that in 2009?
Offer a very short reply. 0.87. What is the ratio of the Area (in %) of Bahrain in 2008 to that in 2009?
Your answer should be very brief. 0.98. What is the ratio of the Area (in %) in Gabon in 2008 to that in 2009?
Make the answer very short. 1. What is the difference between the highest and the second highest Area (in %) in Bahrain?
Provide a succinct answer. 0.6. What is the difference between the highest and the second highest Area (in %) in Haiti?
Make the answer very short. 0.86. What is the difference between the highest and the second highest Area (in %) in Papua New Guinea?
Offer a terse response. 0. What is the difference between the highest and the lowest Area (in %) in Bahrain?
Your response must be concise. 2.17. What is the difference between the highest and the lowest Area (in %) of Gabon?
Your answer should be very brief. 0. What is the difference between the highest and the lowest Area (in %) of Haiti?
Your answer should be compact. 5.44. What is the difference between the highest and the lowest Area (in %) in Papua New Guinea?
Your answer should be compact. 0.42. 